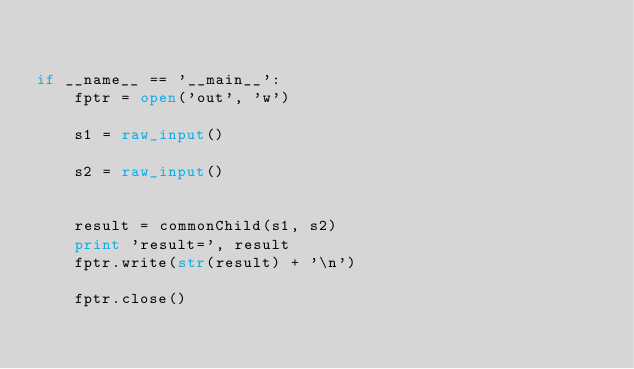<code> <loc_0><loc_0><loc_500><loc_500><_Python_>

if __name__ == '__main__':
    fptr = open('out', 'w')

    s1 = raw_input()

    s2 = raw_input()


    result = commonChild(s1, s2)
    print 'result=', result
    fptr.write(str(result) + '\n')

    fptr.close()
</code> 